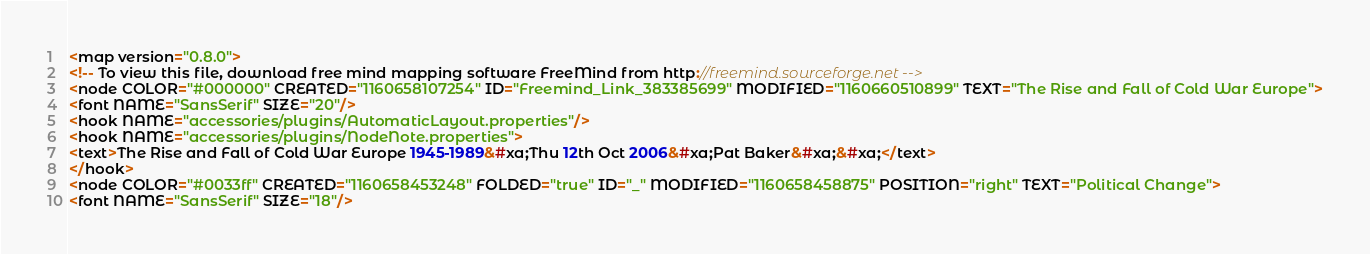<code> <loc_0><loc_0><loc_500><loc_500><_ObjectiveC_><map version="0.8.0">
<!-- To view this file, download free mind mapping software FreeMind from http://freemind.sourceforge.net -->
<node COLOR="#000000" CREATED="1160658107254" ID="Freemind_Link_383385699" MODIFIED="1160660510899" TEXT="The Rise and Fall of Cold War Europe">
<font NAME="SansSerif" SIZE="20"/>
<hook NAME="accessories/plugins/AutomaticLayout.properties"/>
<hook NAME="accessories/plugins/NodeNote.properties">
<text>The Rise and Fall of Cold War Europe 1945-1989&#xa;Thu 12th Oct 2006&#xa;Pat Baker&#xa;&#xa;</text>
</hook>
<node COLOR="#0033ff" CREATED="1160658453248" FOLDED="true" ID="_" MODIFIED="1160658458875" POSITION="right" TEXT="Political Change">
<font NAME="SansSerif" SIZE="18"/></code> 